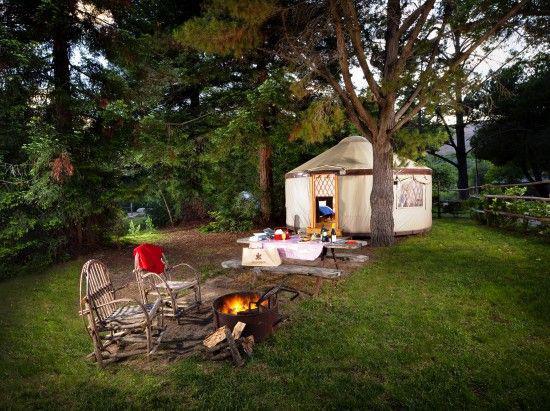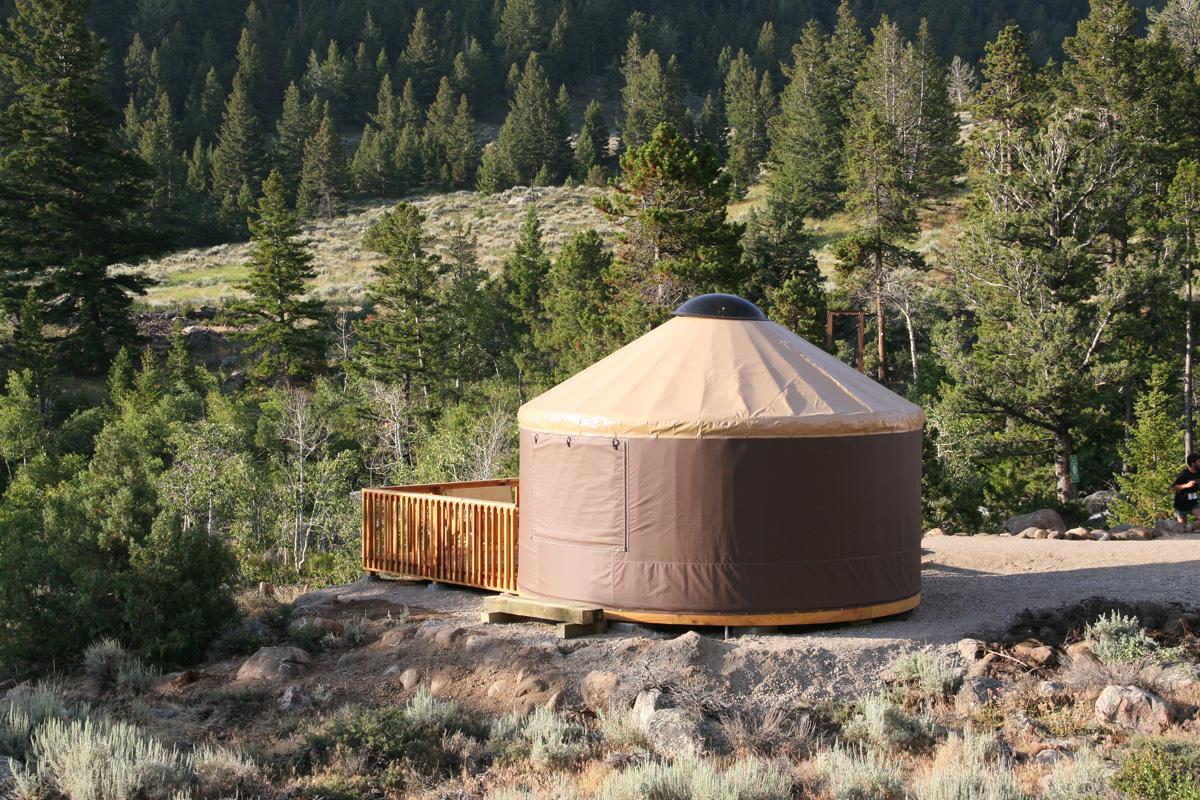The first image is the image on the left, the second image is the image on the right. For the images shown, is this caption "An image shows a green yurt with a pale roof, and it is surrounded by a square railed deck." true? Answer yes or no. No. The first image is the image on the left, the second image is the image on the right. Considering the images on both sides, is "Two yurts are situated in a woody area on square wooden decks with railings, one of them dark green and the other a different color." valid? Answer yes or no. No. The first image is the image on the left, the second image is the image on the right. Considering the images on both sides, is "The left image contains a cottage surrounded by a wooden railing." valid? Answer yes or no. No. The first image is the image on the left, the second image is the image on the right. Assess this claim about the two images: "Multiple lawn chairs are on the ground in front of a round building with a cone-shaped roof.". Correct or not? Answer yes or no. Yes. 